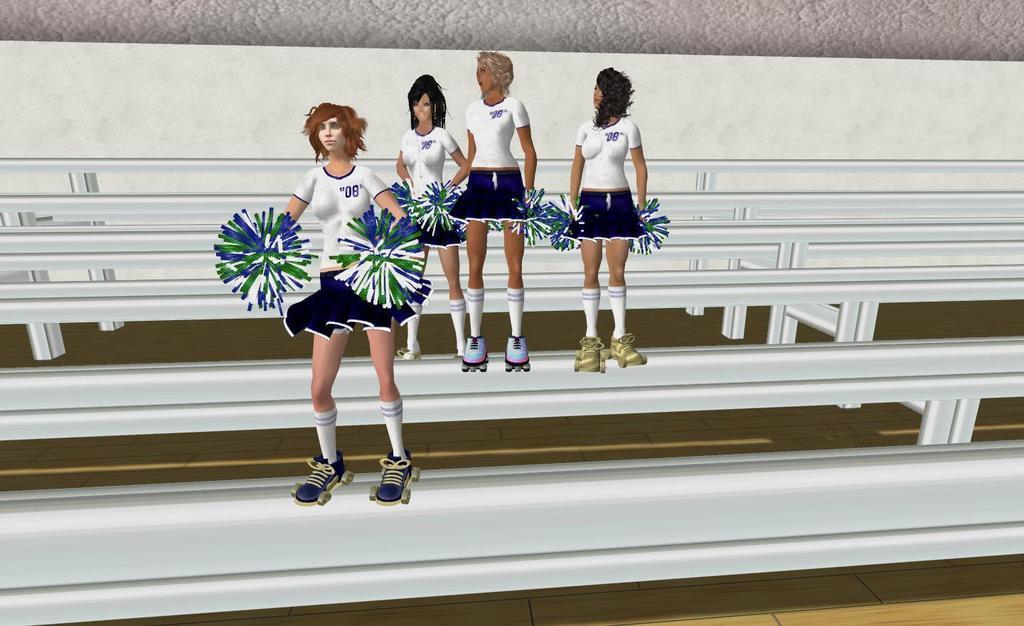Please provide a concise description of this image. In this image we can see an animated picture of a group of woman wearing skates and holding pom poms is standing on the poles. 